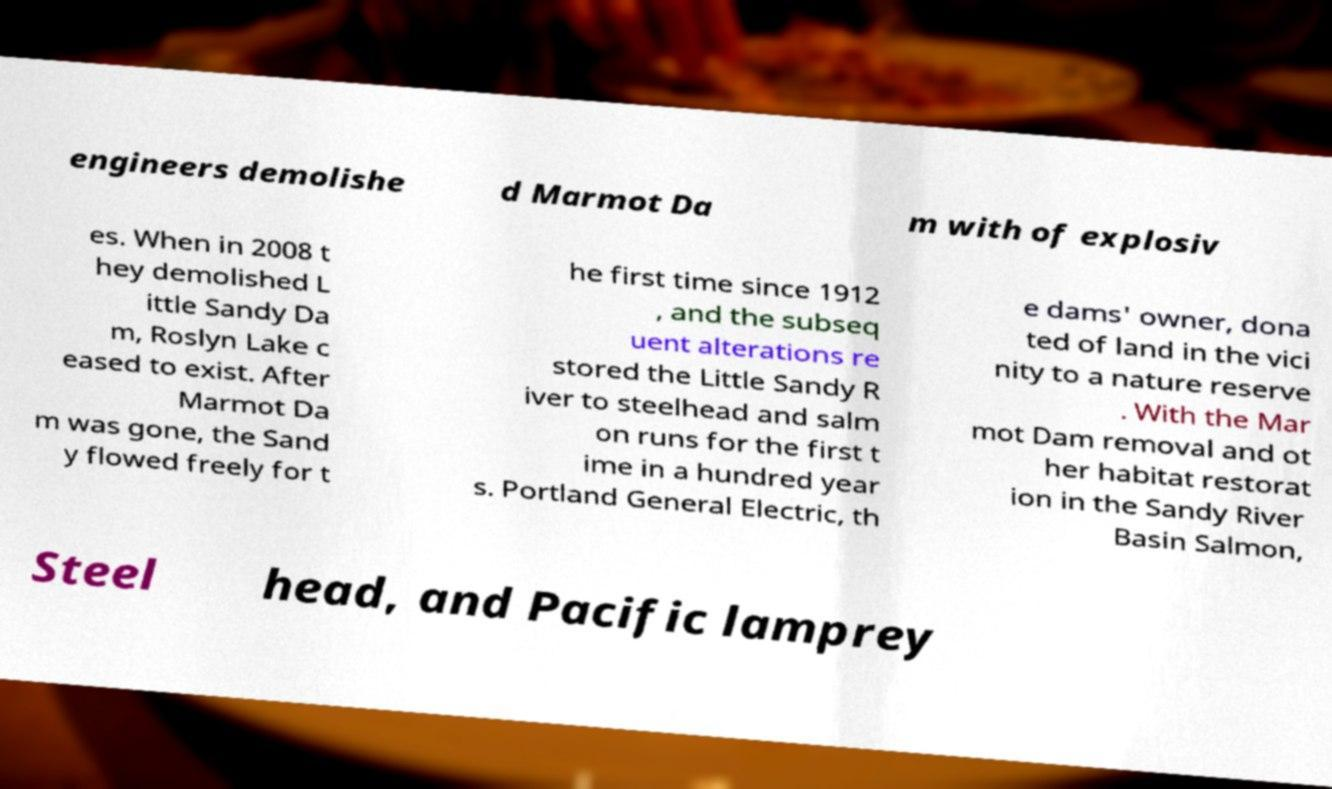For documentation purposes, I need the text within this image transcribed. Could you provide that? engineers demolishe d Marmot Da m with of explosiv es. When in 2008 t hey demolished L ittle Sandy Da m, Roslyn Lake c eased to exist. After Marmot Da m was gone, the Sand y flowed freely for t he first time since 1912 , and the subseq uent alterations re stored the Little Sandy R iver to steelhead and salm on runs for the first t ime in a hundred year s. Portland General Electric, th e dams' owner, dona ted of land in the vici nity to a nature reserve . With the Mar mot Dam removal and ot her habitat restorat ion in the Sandy River Basin Salmon, Steel head, and Pacific lamprey 